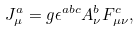Convert formula to latex. <formula><loc_0><loc_0><loc_500><loc_500>J _ { \mu } ^ { a } = g \epsilon ^ { a b c } A _ { \nu } ^ { b } F _ { \mu \nu } ^ { c } ,</formula> 